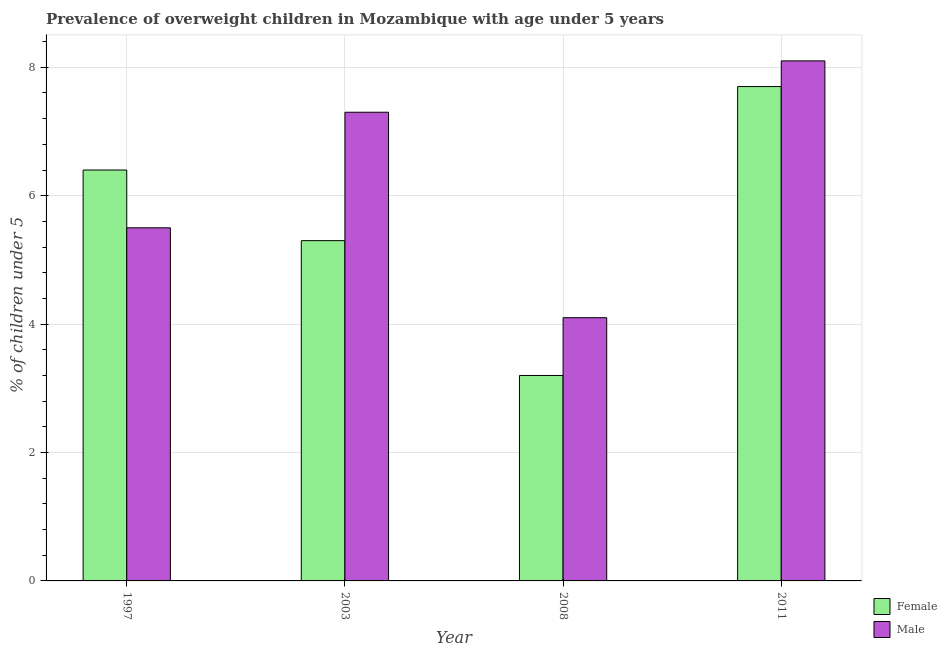Are the number of bars per tick equal to the number of legend labels?
Keep it short and to the point. Yes. How many bars are there on the 4th tick from the right?
Your answer should be compact. 2. What is the label of the 1st group of bars from the left?
Give a very brief answer. 1997. In how many cases, is the number of bars for a given year not equal to the number of legend labels?
Offer a very short reply. 0. What is the percentage of obese male children in 2011?
Ensure brevity in your answer.  8.1. Across all years, what is the maximum percentage of obese female children?
Keep it short and to the point. 7.7. Across all years, what is the minimum percentage of obese female children?
Ensure brevity in your answer.  3.2. In which year was the percentage of obese male children maximum?
Make the answer very short. 2011. What is the total percentage of obese female children in the graph?
Offer a terse response. 22.6. What is the difference between the percentage of obese male children in 1997 and that in 2011?
Give a very brief answer. -2.6. What is the difference between the percentage of obese female children in 1997 and the percentage of obese male children in 2008?
Provide a short and direct response. 3.2. What is the average percentage of obese female children per year?
Offer a terse response. 5.65. What is the ratio of the percentage of obese female children in 2003 to that in 2008?
Ensure brevity in your answer.  1.66. What is the difference between the highest and the second highest percentage of obese female children?
Your response must be concise. 1.3. What is the difference between the highest and the lowest percentage of obese male children?
Offer a terse response. 4. Is the sum of the percentage of obese male children in 2003 and 2011 greater than the maximum percentage of obese female children across all years?
Provide a succinct answer. Yes. What does the 1st bar from the left in 1997 represents?
Give a very brief answer. Female. What does the 1st bar from the right in 2003 represents?
Provide a short and direct response. Male. Are all the bars in the graph horizontal?
Make the answer very short. No. How many years are there in the graph?
Give a very brief answer. 4. Does the graph contain any zero values?
Give a very brief answer. No. Does the graph contain grids?
Ensure brevity in your answer.  Yes. How are the legend labels stacked?
Make the answer very short. Vertical. What is the title of the graph?
Your answer should be very brief. Prevalence of overweight children in Mozambique with age under 5 years. What is the label or title of the X-axis?
Make the answer very short. Year. What is the label or title of the Y-axis?
Offer a terse response.  % of children under 5. What is the  % of children under 5 of Female in 1997?
Your answer should be compact. 6.4. What is the  % of children under 5 in Male in 1997?
Your response must be concise. 5.5. What is the  % of children under 5 in Female in 2003?
Ensure brevity in your answer.  5.3. What is the  % of children under 5 of Male in 2003?
Your answer should be compact. 7.3. What is the  % of children under 5 of Female in 2008?
Your answer should be compact. 3.2. What is the  % of children under 5 of Male in 2008?
Make the answer very short. 4.1. What is the  % of children under 5 in Female in 2011?
Your answer should be very brief. 7.7. What is the  % of children under 5 in Male in 2011?
Ensure brevity in your answer.  8.1. Across all years, what is the maximum  % of children under 5 of Female?
Keep it short and to the point. 7.7. Across all years, what is the maximum  % of children under 5 of Male?
Your response must be concise. 8.1. Across all years, what is the minimum  % of children under 5 of Female?
Keep it short and to the point. 3.2. Across all years, what is the minimum  % of children under 5 in Male?
Make the answer very short. 4.1. What is the total  % of children under 5 in Female in the graph?
Offer a very short reply. 22.6. What is the total  % of children under 5 of Male in the graph?
Your answer should be compact. 25. What is the difference between the  % of children under 5 of Female in 1997 and that in 2003?
Provide a succinct answer. 1.1. What is the difference between the  % of children under 5 in Male in 1997 and that in 2008?
Provide a short and direct response. 1.4. What is the difference between the  % of children under 5 of Female in 1997 and that in 2011?
Keep it short and to the point. -1.3. What is the difference between the  % of children under 5 in Male in 1997 and that in 2011?
Your response must be concise. -2.6. What is the difference between the  % of children under 5 of Male in 2003 and that in 2008?
Offer a terse response. 3.2. What is the difference between the  % of children under 5 in Female in 1997 and the  % of children under 5 in Male in 2003?
Offer a terse response. -0.9. What is the difference between the  % of children under 5 of Female in 1997 and the  % of children under 5 of Male in 2008?
Offer a terse response. 2.3. What is the difference between the  % of children under 5 of Female in 2003 and the  % of children under 5 of Male in 2011?
Your answer should be very brief. -2.8. What is the average  % of children under 5 in Female per year?
Your answer should be very brief. 5.65. What is the average  % of children under 5 in Male per year?
Make the answer very short. 6.25. In the year 1997, what is the difference between the  % of children under 5 of Female and  % of children under 5 of Male?
Offer a terse response. 0.9. In the year 2003, what is the difference between the  % of children under 5 of Female and  % of children under 5 of Male?
Offer a terse response. -2. In the year 2008, what is the difference between the  % of children under 5 in Female and  % of children under 5 in Male?
Your answer should be very brief. -0.9. In the year 2011, what is the difference between the  % of children under 5 of Female and  % of children under 5 of Male?
Your response must be concise. -0.4. What is the ratio of the  % of children under 5 of Female in 1997 to that in 2003?
Make the answer very short. 1.21. What is the ratio of the  % of children under 5 in Male in 1997 to that in 2003?
Offer a very short reply. 0.75. What is the ratio of the  % of children under 5 in Female in 1997 to that in 2008?
Give a very brief answer. 2. What is the ratio of the  % of children under 5 in Male in 1997 to that in 2008?
Give a very brief answer. 1.34. What is the ratio of the  % of children under 5 in Female in 1997 to that in 2011?
Provide a short and direct response. 0.83. What is the ratio of the  % of children under 5 of Male in 1997 to that in 2011?
Provide a short and direct response. 0.68. What is the ratio of the  % of children under 5 of Female in 2003 to that in 2008?
Offer a terse response. 1.66. What is the ratio of the  % of children under 5 of Male in 2003 to that in 2008?
Give a very brief answer. 1.78. What is the ratio of the  % of children under 5 of Female in 2003 to that in 2011?
Your response must be concise. 0.69. What is the ratio of the  % of children under 5 of Male in 2003 to that in 2011?
Provide a short and direct response. 0.9. What is the ratio of the  % of children under 5 in Female in 2008 to that in 2011?
Your response must be concise. 0.42. What is the ratio of the  % of children under 5 of Male in 2008 to that in 2011?
Make the answer very short. 0.51. What is the difference between the highest and the second highest  % of children under 5 in Female?
Your answer should be very brief. 1.3. What is the difference between the highest and the second highest  % of children under 5 of Male?
Ensure brevity in your answer.  0.8. What is the difference between the highest and the lowest  % of children under 5 in Female?
Your answer should be compact. 4.5. 